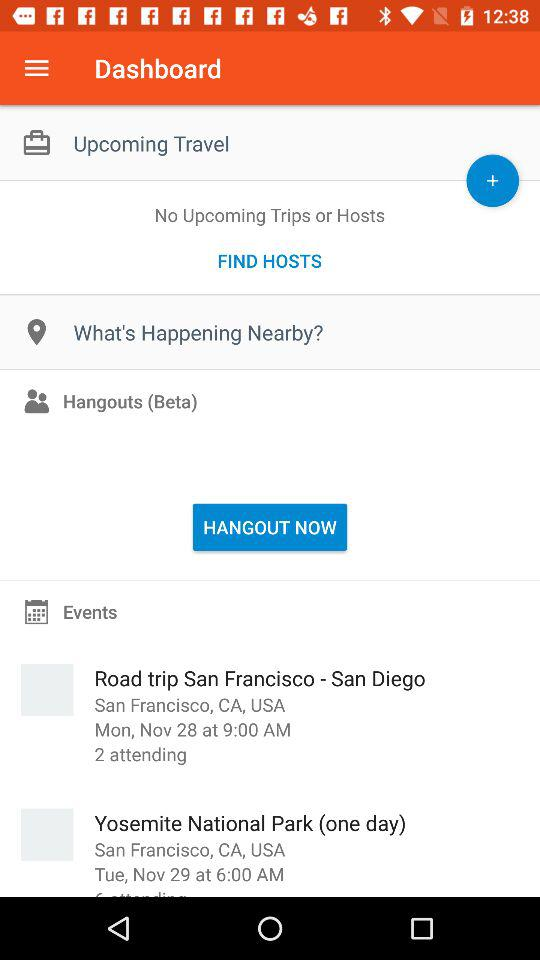When will the event take place at "Yosemite National Park"? The event will take place at "Yosemite National Park" on Tuesday, November 29 at 6:00 a.m. 